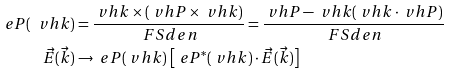<formula> <loc_0><loc_0><loc_500><loc_500>\ e P ( \ v h k ) & = \frac { \ v h k \times ( \ v h P \times \ v h k ) } { \ F S d e n } = \frac { \ v h P - \ v h k ( \ v h k \cdot \ v h P ) } { \ F S d e n } \\ \vec { E } ( \vec { k } ) & \rightarrow \ e P ( \ v h k ) \, \left [ \ e P ^ { \ast } ( \ v h k ) \cdot \vec { E } ( \vec { k } ) \right ]</formula> 